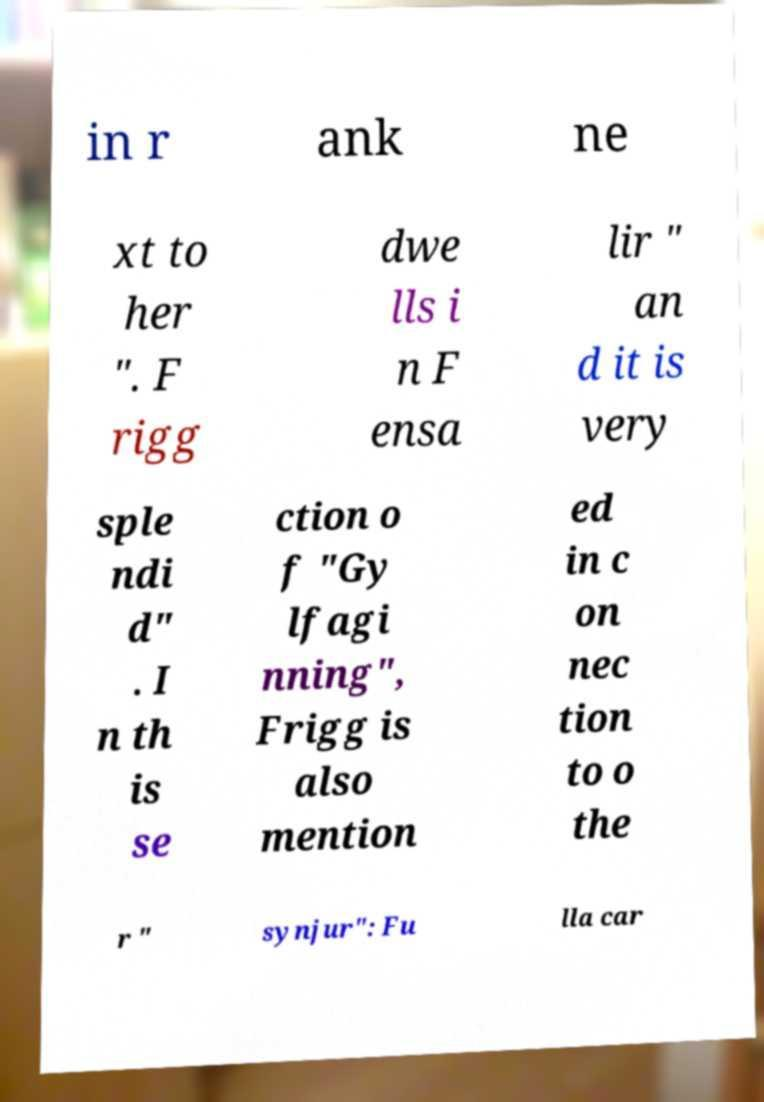Can you read and provide the text displayed in the image?This photo seems to have some interesting text. Can you extract and type it out for me? in r ank ne xt to her ". F rigg dwe lls i n F ensa lir " an d it is very sple ndi d" . I n th is se ction o f "Gy lfagi nning", Frigg is also mention ed in c on nec tion to o the r " synjur": Fu lla car 